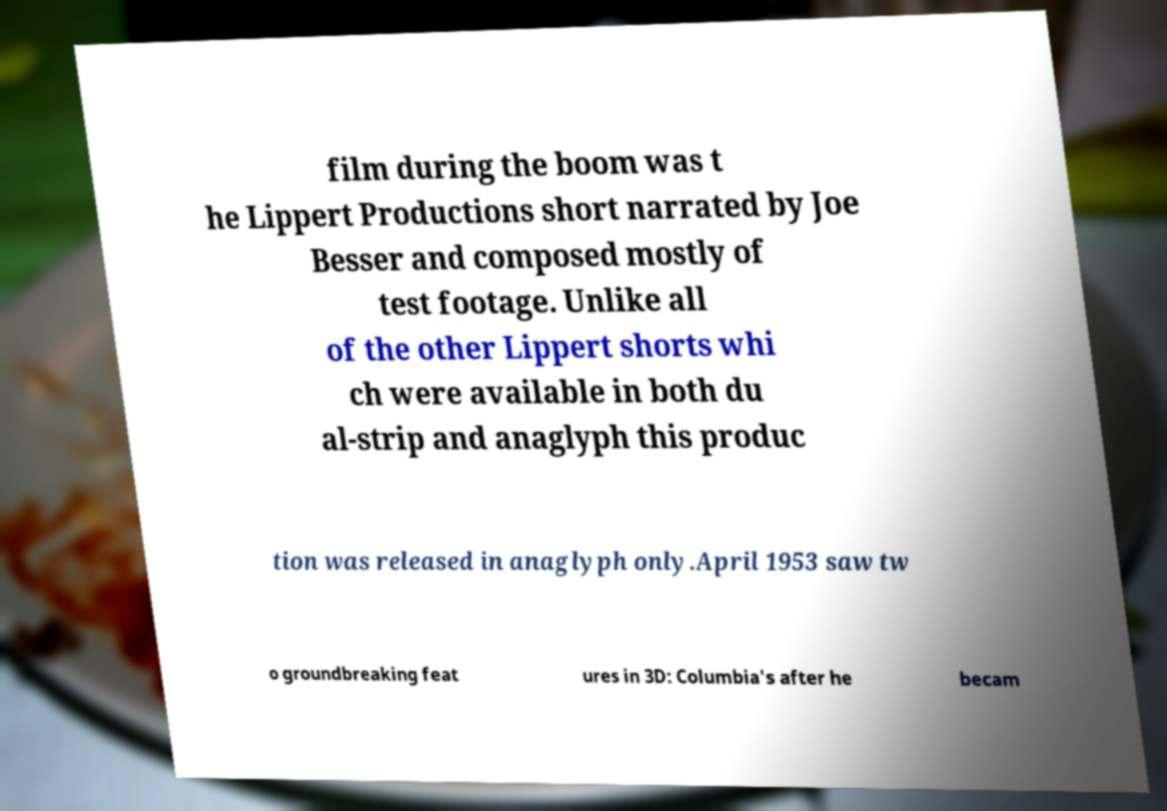For documentation purposes, I need the text within this image transcribed. Could you provide that? film during the boom was t he Lippert Productions short narrated by Joe Besser and composed mostly of test footage. Unlike all of the other Lippert shorts whi ch were available in both du al-strip and anaglyph this produc tion was released in anaglyph only.April 1953 saw tw o groundbreaking feat ures in 3D: Columbia's after he becam 